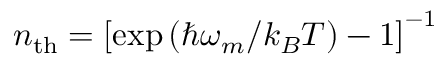<formula> <loc_0><loc_0><loc_500><loc_500>n _ { t h } = \left [ \exp { ( \hbar { \omega } _ { m } / k _ { B } T ) } - 1 \right ] ^ { - 1 }</formula> 